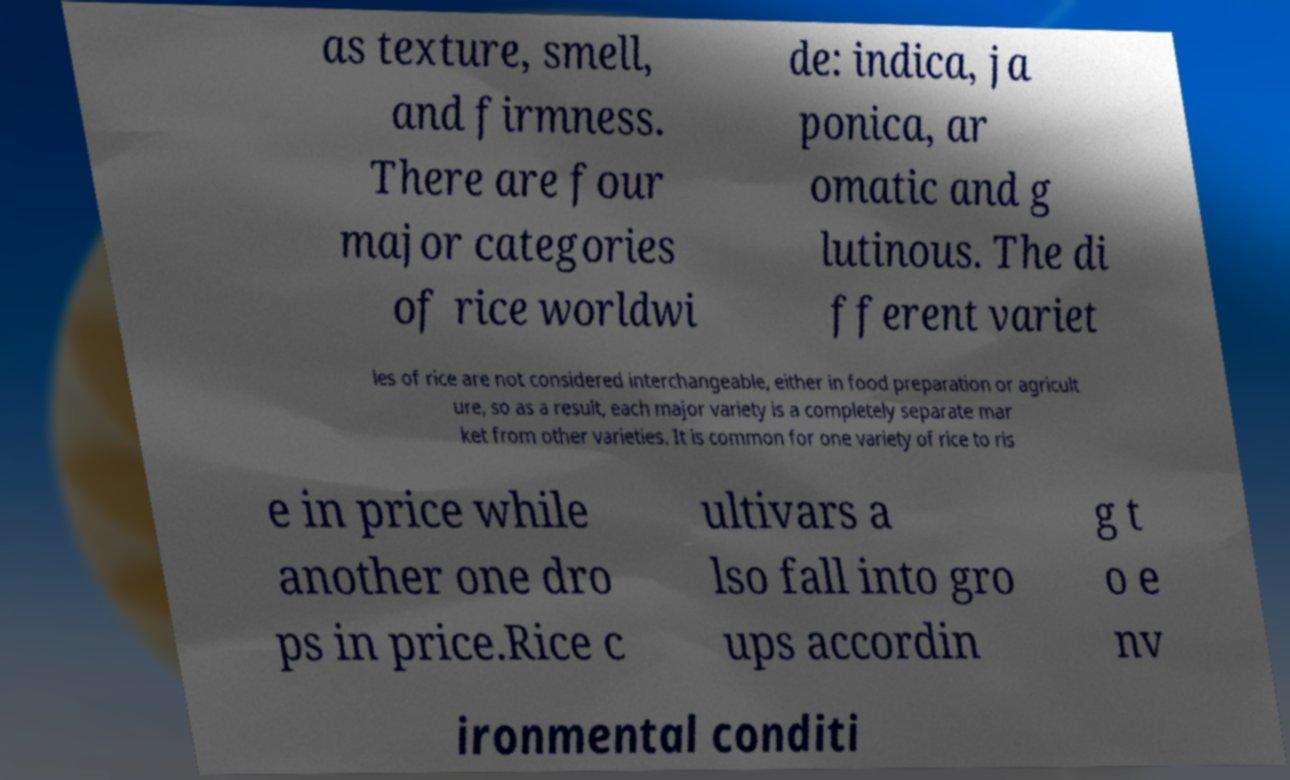Please read and relay the text visible in this image. What does it say? as texture, smell, and firmness. There are four major categories of rice worldwi de: indica, ja ponica, ar omatic and g lutinous. The di fferent variet ies of rice are not considered interchangeable, either in food preparation or agricult ure, so as a result, each major variety is a completely separate mar ket from other varieties. It is common for one variety of rice to ris e in price while another one dro ps in price.Rice c ultivars a lso fall into gro ups accordin g t o e nv ironmental conditi 